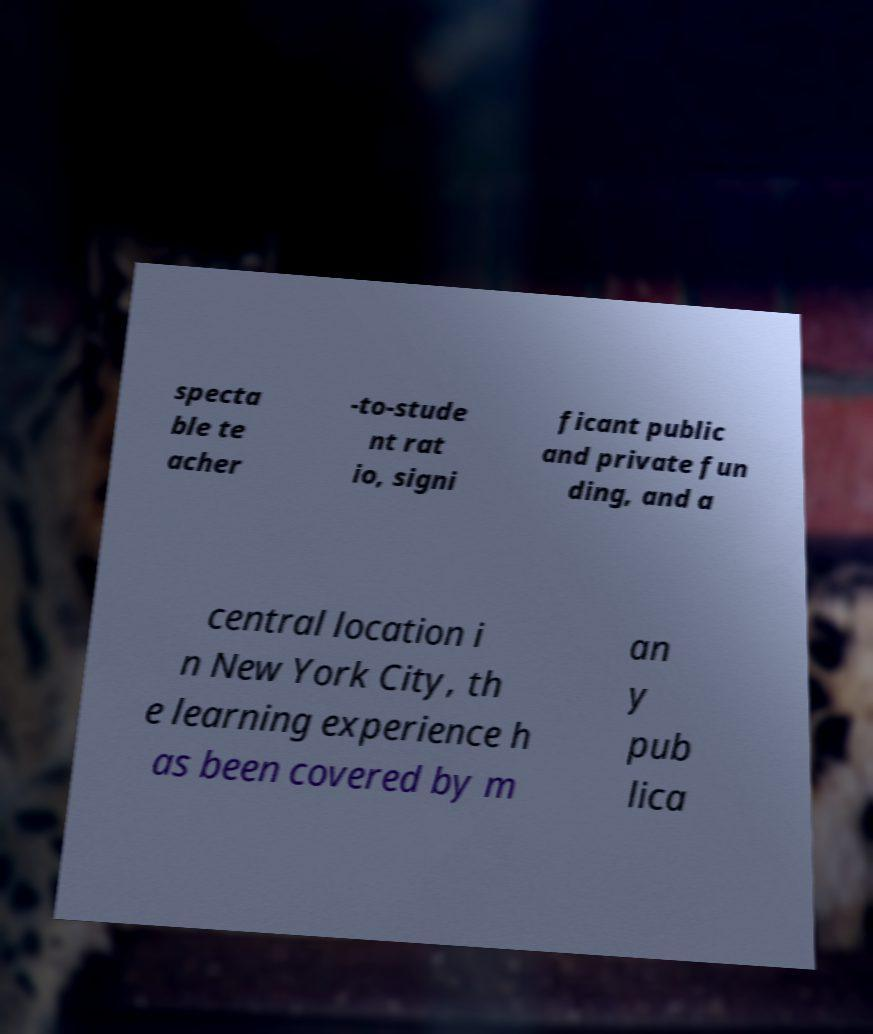For documentation purposes, I need the text within this image transcribed. Could you provide that? specta ble te acher -to-stude nt rat io, signi ficant public and private fun ding, and a central location i n New York City, th e learning experience h as been covered by m an y pub lica 